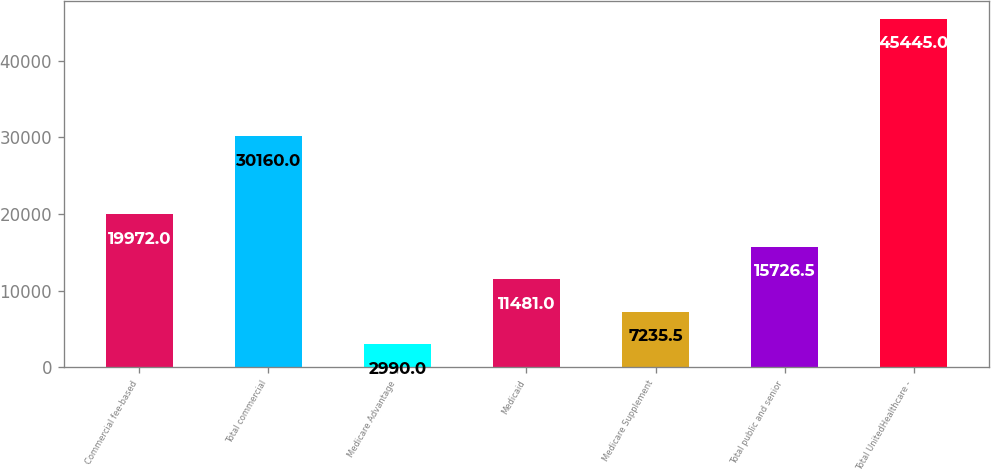Convert chart to OTSL. <chart><loc_0><loc_0><loc_500><loc_500><bar_chart><fcel>Commercial fee-based<fcel>Total commercial<fcel>Medicare Advantage<fcel>Medicaid<fcel>Medicare Supplement<fcel>Total public and senior<fcel>Total UnitedHealthcare -<nl><fcel>19972<fcel>30160<fcel>2990<fcel>11481<fcel>7235.5<fcel>15726.5<fcel>45445<nl></chart> 